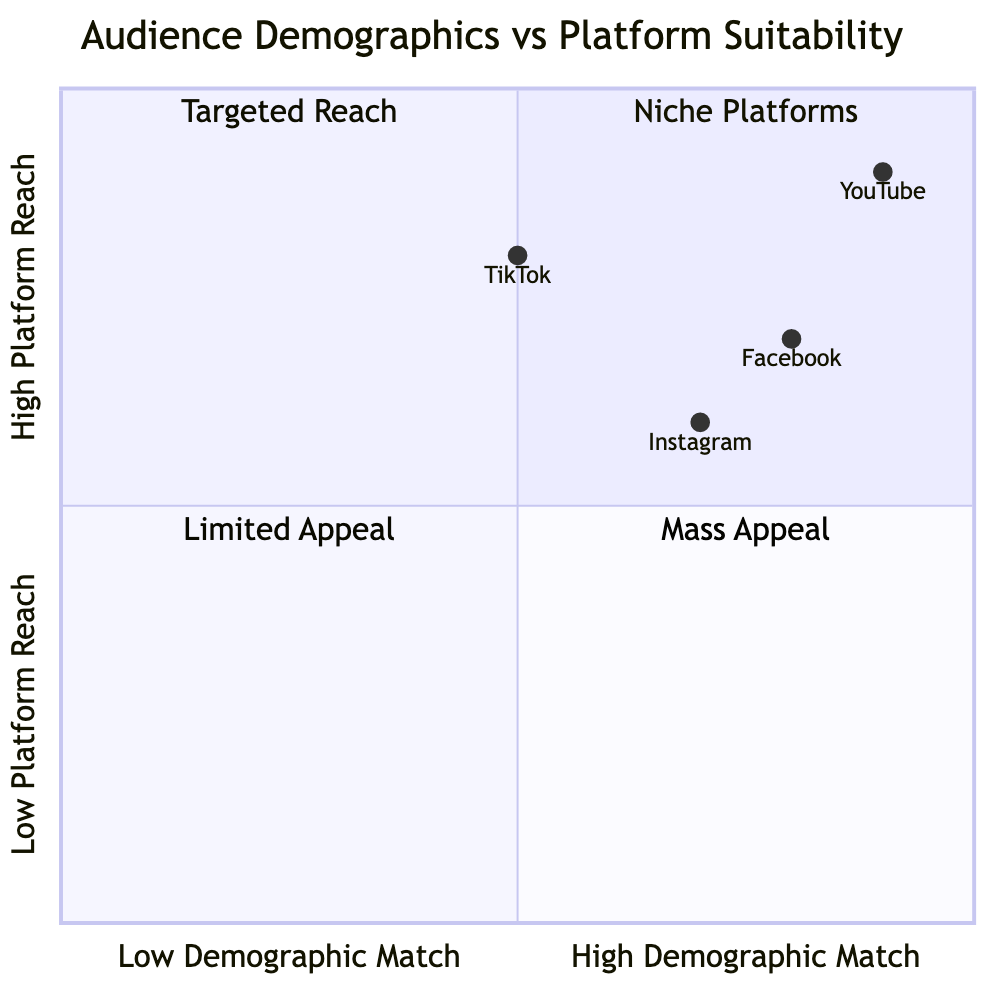What platform has the highest demographic match? By examining the quadrant chart, I can see that YouTube is positioned closest to the upper right corner, which represents high demographic match. Its coordinates are [0.9, 0.9], indicating both high suitability for demographics and a strong platform reach.
Answer: YouTube What is the demographic match value for Instagram? The chart indicates that Instagram has a demographic match value of 0.7, which is derived from its positioning on the x-axis of the quadrant chart.
Answer: 0.7 How many platforms fall into the Mass Appeal quadrant? Looking at the quadrant chart, both Facebook and YouTube are positioned in the Mass Appeal quadrant, indicated by their coordinates falling within that area.
Answer: 2 Which platform is suitable for the age group 25-34? I can identify Facebook and Instagram in the chart, as both have demographic suitability for the 25-34 age group, according to the provided data.
Answer: Facebook, Instagram Which platform has the lowest reach? The quadrant chart shows TikTok positioned at [0.5, 0.8], which indicates it has the lowest platform reach among the options presented, as it is lower on the y-axis compared to others like YouTube and Facebook.
Answer: TikTok Which two platforms target the same gender demographics? In examining the chart and demographic categories, Instagram and Facebook both target Male and Female gender groups, which allows us to identify them as having overlapping gender suitability.
Answer: Instagram, Facebook What is the y-axis value for Facebook? The y-axis value for Facebook, as indicated at its coordinate on the quadrant chart, is 0.7, signifying the level of platform reach it has.
Answer: 0.7 What quadrant is TikTok in? TikTok's coordinates at [0.5, 0.8] place it within the Targeted Reach quadrant, which is specifically designated for platforms with medium demographic match and high platform reach.
Answer: Targeted Reach Which platform caters to all age groups listed? By analyzing the suitable demographics for each platform, I can conclude that YouTube has suitable demographics for the age groups 18-24, 25-34, and 35-44, thereby catering to all specified age groups.
Answer: YouTube 